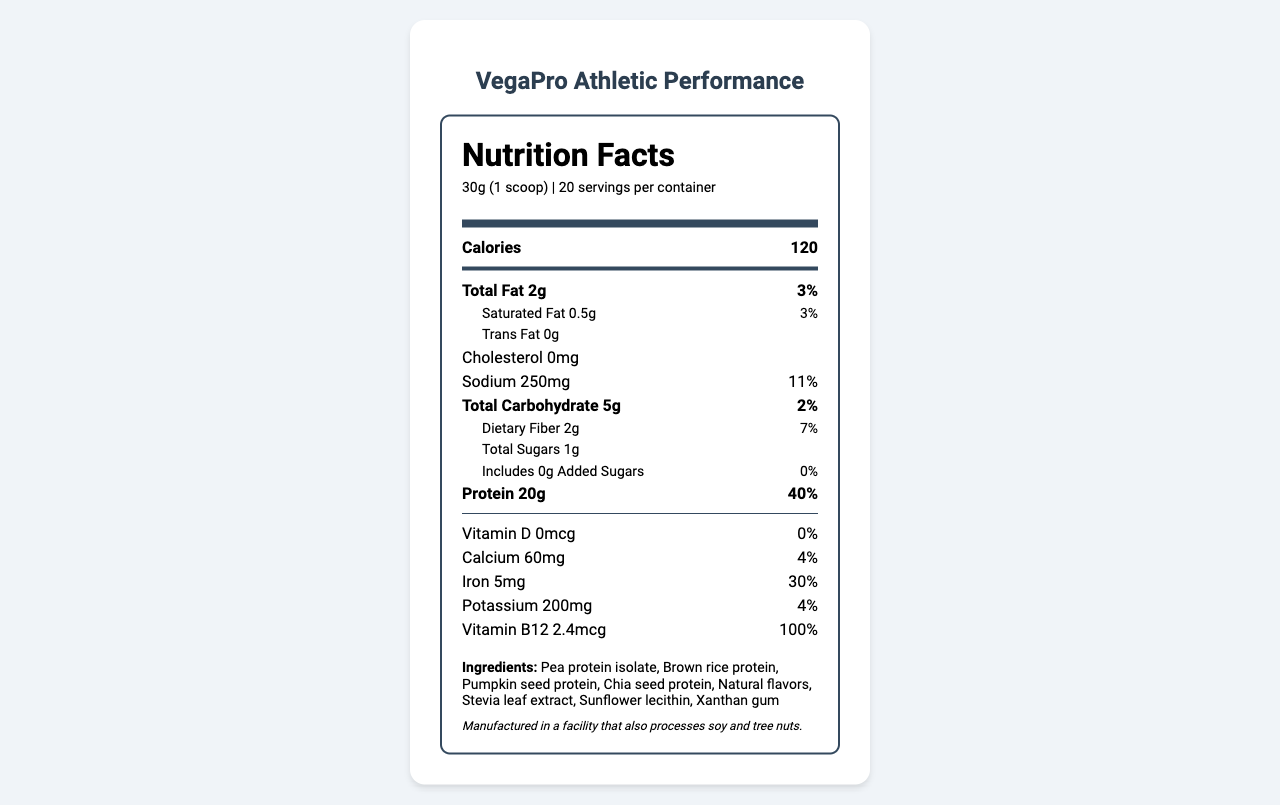what is the serving size of VegaPro Athletic Performance? The serving size is clearly mentioned at the top of the Nutrition Facts panel as "30g (1 scoop)".
Answer: 30g (1 scoop) how many servings are there in one container? The document states that there are 20 servings per container under the serving size information.
Answer: 20 how much protein is in each serving? The amount of protein per serving is listed in the Nutrition Facts as "Protein 20g".
Answer: 20g what is the percentage of the daily value for sodium? The daily value percent for sodium is listed as "11%" in the Nutrition Facts.
Answer: 11% does this product contain any cholesterol? The Nutrition Facts panel lists "Cholesterol 0mg", indicating there is no cholesterol in the product.
Answer: No what are the main ingredients in VegaPro Athletic Performance? The ingredients are listed towards the bottom of the document.
Answer: Pea protein isolate, Brown rice protein, Pumpkin seed protein, Chia seed protein, Natural flavors, Stevia leaf extract, Sunflower lecithin, Xanthan gum which vitamin has the highest daily value percentage? 
   A. Vitamin D
   B. Calcium
   C. Iron
   D. Vitamin B12 The document lists the daily value for Vitamin B12 as 100%, which is the highest among the vitamins mentioned.
Answer: D. Vitamin B12 how many grams of total fat are there per serving? 
   A. 2g
   B. 1g
   C. 0.5g 
   D. 3g Total Fat per serving is mentioned as "Total Fat 2g" in the Nutrition Facts.
Answer: A. 2g is this product suitable for people with nut allergies? The allergen information states "Manufactured in a facility that also processes soy and tree nuts", indicating potential cross-contamination with nuts.
Answer: No summarize the main nutritional benefits and ingredients of VegaPro Athletic Performance. The document details the nutritional content and ingredients, emphasizing high protein content and the inclusion of essential vitamins like B12.
Answer: VegaPro Athletic Performance is a vegan protein powder supplement meant for athletes. Each 30g serving provides 120 calories, 2g of total fat, 250mg of sodium, 5g of total carbohydrates, 2g of dietary fiber, 1g of total sugars, and 20g of protein. It also contains various vitamins and minerals, including Vitamin B12 (100% daily value) and iron (30% daily value). The product's main ingredients are various plant-based proteins like pea protein isolate, brown rice protein, and others. what is the added sugars amount per serving? The Nutrition Facts section lists the added sugars as "Includes 0g Added Sugars".
Answer: 0g how much iron is in each serving, and what is its daily value percentage? According to the Nutrition Facts, each serving contains 5mg of iron, and this represents 30% of the daily value.
Answer: 5mg, 30% what is the primary purpose of VegaPro Athletic Performance according to the document? The product name and its nutritional content, with a high amount of protein per serving, indicate it is intended as a supplement for athletes.
Answer: Supplement for athletes is the cost of producing this product higher than traditional whey protein? The document mentions that the cost "may be higher" but does not provide specific cost comparisons or data.
Answer: Not enough information how many total grams of carbohydrates are there in one serving? The total carbohydrate content per serving is indicated as 5g in the Nutrition Facts.
Answer: 5g what is the daily value percentage for dietary fiber per serving? The daily value for dietary fiber per serving is 7%, as listed in the Nutrition Facts.
Answer: 7% 